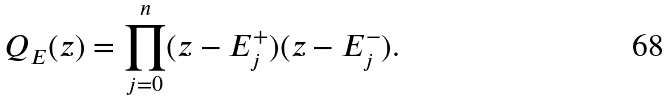<formula> <loc_0><loc_0><loc_500><loc_500>Q _ { E } ( z ) = \prod _ { j = 0 } ^ { n } ( z - E _ { j } ^ { + } ) ( z - E _ { j } ^ { - } ) .</formula> 